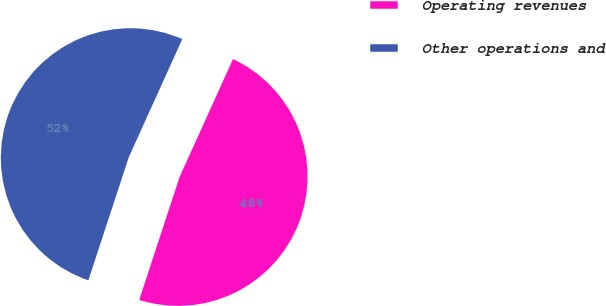<chart> <loc_0><loc_0><loc_500><loc_500><pie_chart><fcel>Operating revenues<fcel>Other operations and<nl><fcel>48.28%<fcel>51.72%<nl></chart> 